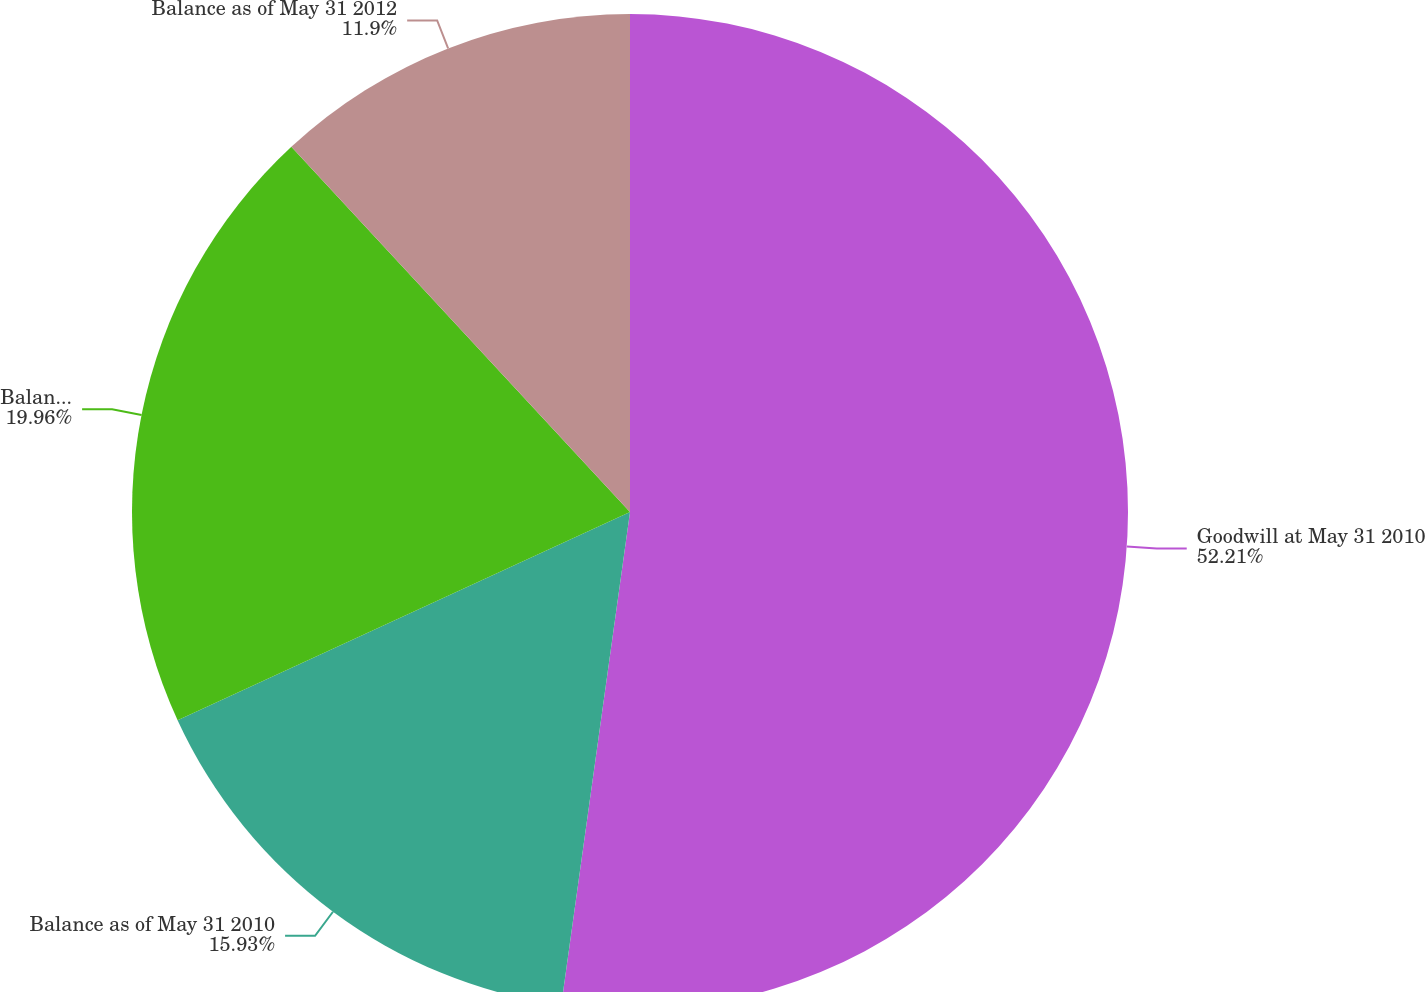<chart> <loc_0><loc_0><loc_500><loc_500><pie_chart><fcel>Goodwill at May 31 2010<fcel>Balance as of May 31 2010<fcel>Balance as of May 31 2011<fcel>Balance as of May 31 2012<nl><fcel>52.2%<fcel>15.93%<fcel>19.96%<fcel>11.9%<nl></chart> 